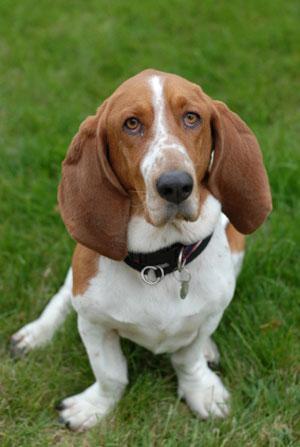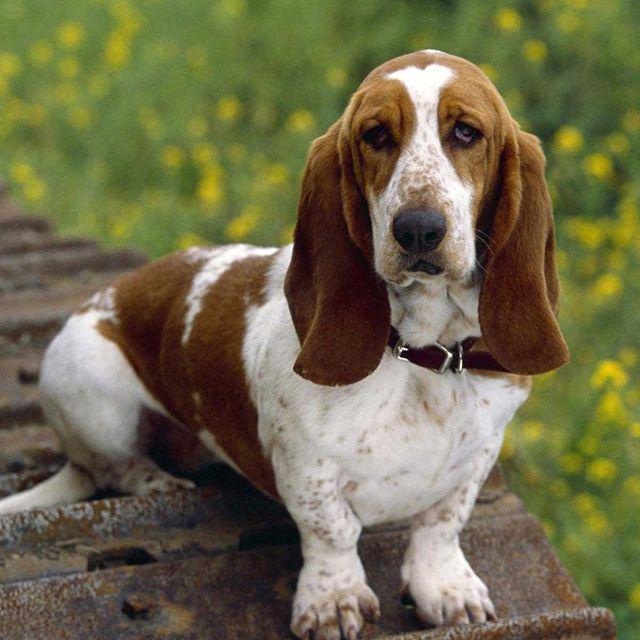The first image is the image on the left, the second image is the image on the right. For the images displayed, is the sentence "One of the dog's front paws are not on the grass." factually correct? Answer yes or no. Yes. The first image is the image on the left, the second image is the image on the right. Given the left and right images, does the statement "All dogs pictured have visible collars." hold true? Answer yes or no. Yes. 